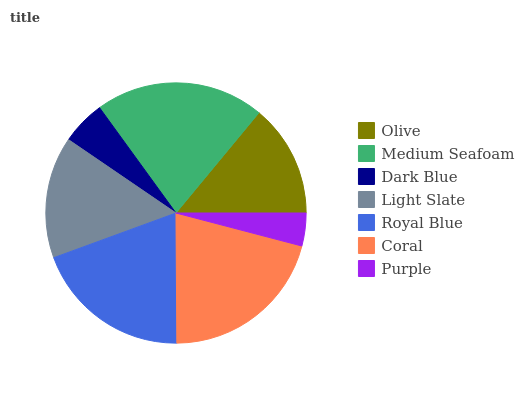Is Purple the minimum?
Answer yes or no. Yes. Is Medium Seafoam the maximum?
Answer yes or no. Yes. Is Dark Blue the minimum?
Answer yes or no. No. Is Dark Blue the maximum?
Answer yes or no. No. Is Medium Seafoam greater than Dark Blue?
Answer yes or no. Yes. Is Dark Blue less than Medium Seafoam?
Answer yes or no. Yes. Is Dark Blue greater than Medium Seafoam?
Answer yes or no. No. Is Medium Seafoam less than Dark Blue?
Answer yes or no. No. Is Light Slate the high median?
Answer yes or no. Yes. Is Light Slate the low median?
Answer yes or no. Yes. Is Purple the high median?
Answer yes or no. No. Is Coral the low median?
Answer yes or no. No. 